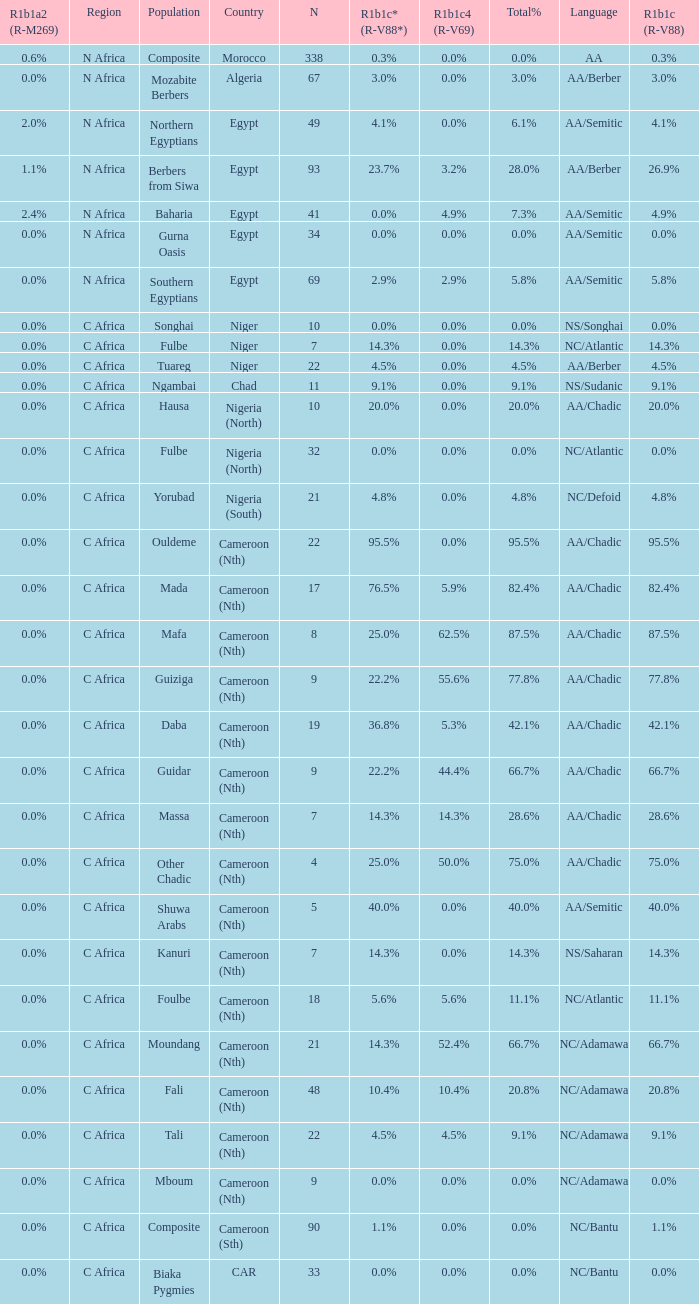Which languages are spoken in niger with r1b1c (r-v88) at NS/Songhai. 